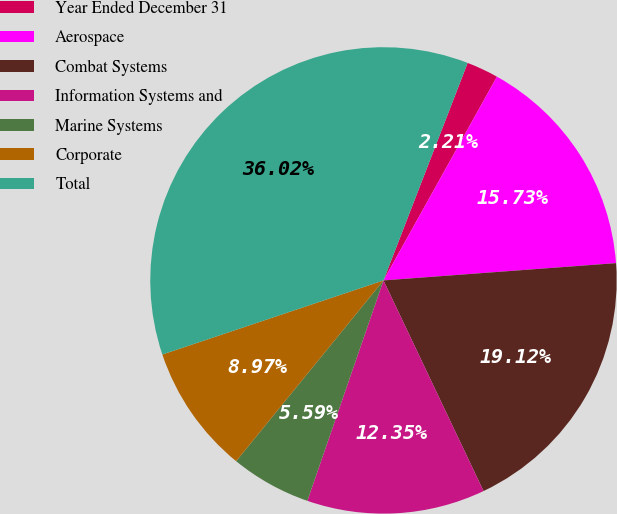<chart> <loc_0><loc_0><loc_500><loc_500><pie_chart><fcel>Year Ended December 31<fcel>Aerospace<fcel>Combat Systems<fcel>Information Systems and<fcel>Marine Systems<fcel>Corporate<fcel>Total<nl><fcel>2.21%<fcel>15.73%<fcel>19.12%<fcel>12.35%<fcel>5.59%<fcel>8.97%<fcel>36.02%<nl></chart> 